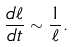Convert formula to latex. <formula><loc_0><loc_0><loc_500><loc_500>\frac { d \ell } { d t } \sim \frac { 1 } { \ell } .</formula> 